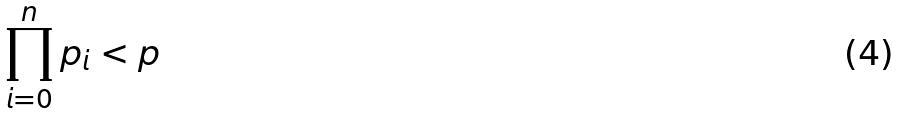<formula> <loc_0><loc_0><loc_500><loc_500>\prod _ { i = 0 } ^ { n } p _ { i } < p</formula> 